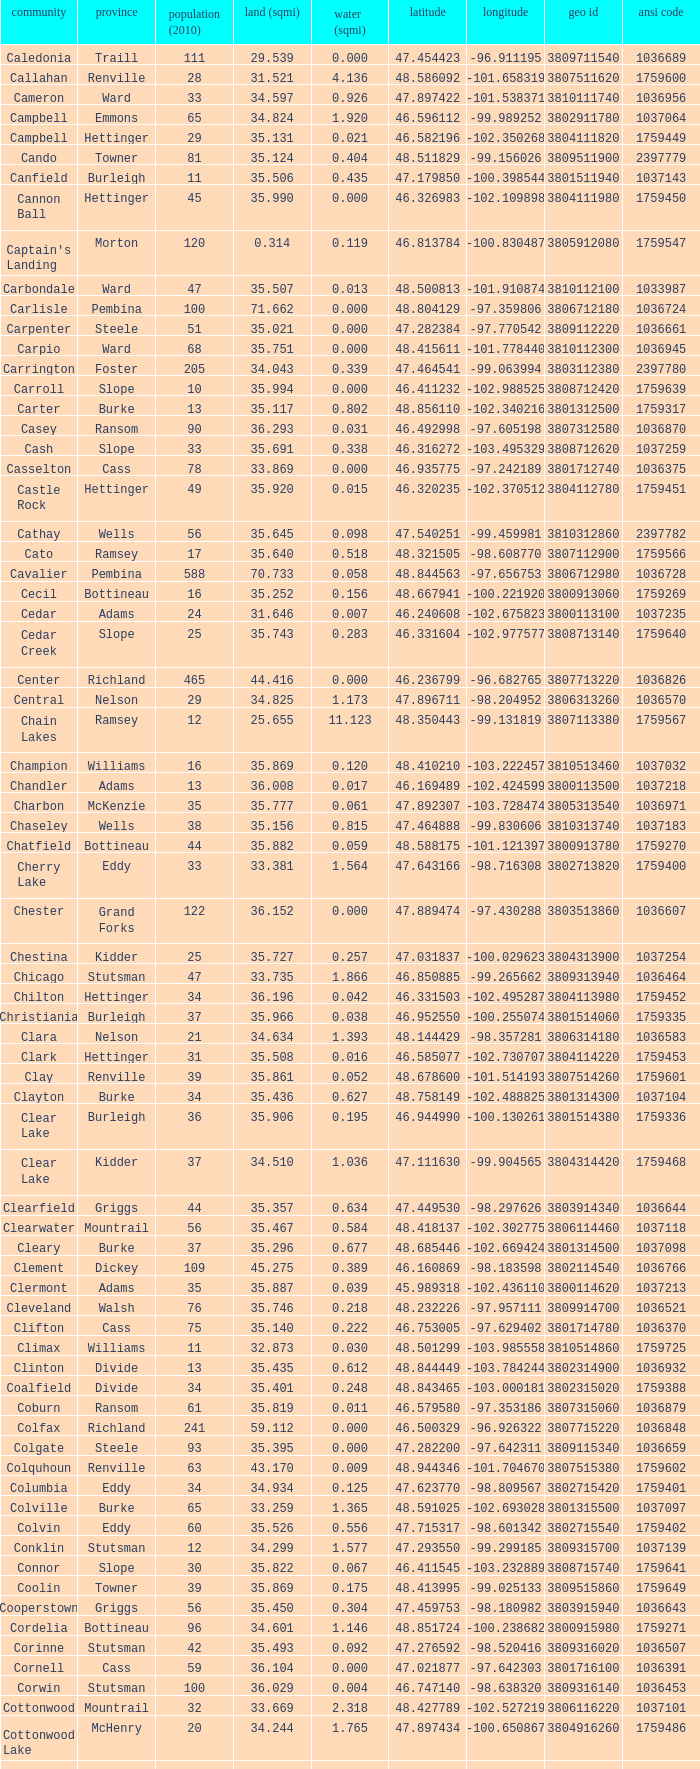What was the township with a geo ID of 3807116660? Creel. 